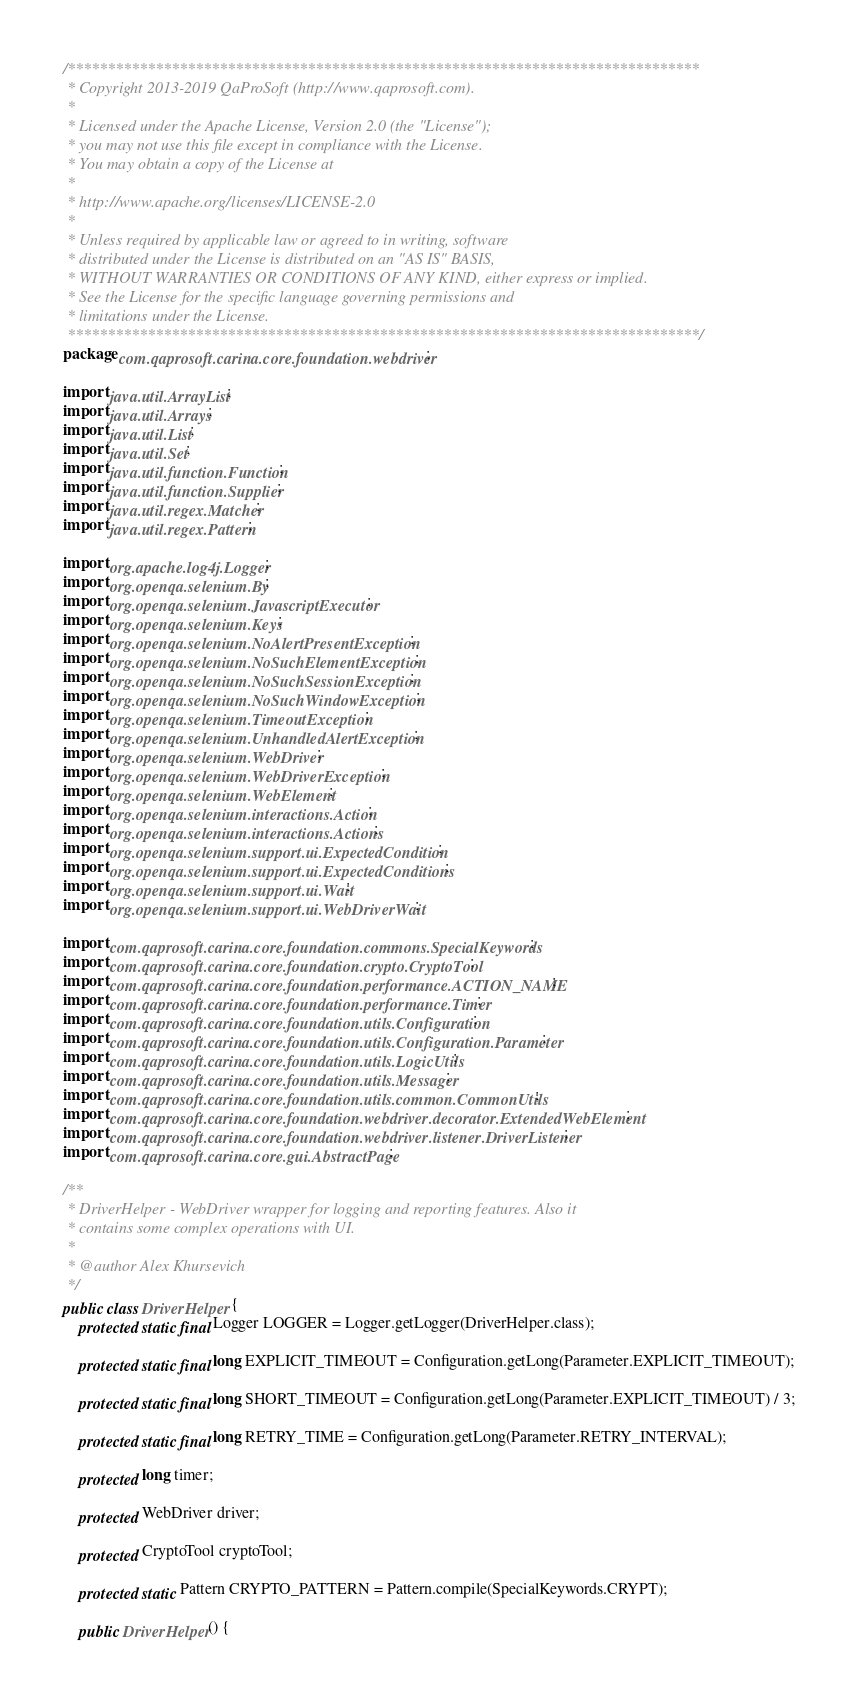Convert code to text. <code><loc_0><loc_0><loc_500><loc_500><_Java_>/*******************************************************************************
 * Copyright 2013-2019 QaProSoft (http://www.qaprosoft.com).
 *
 * Licensed under the Apache License, Version 2.0 (the "License");
 * you may not use this file except in compliance with the License.
 * You may obtain a copy of the License at
 *
 * http://www.apache.org/licenses/LICENSE-2.0
 *
 * Unless required by applicable law or agreed to in writing, software
 * distributed under the License is distributed on an "AS IS" BASIS,
 * WITHOUT WARRANTIES OR CONDITIONS OF ANY KIND, either express or implied.
 * See the License for the specific language governing permissions and
 * limitations under the License.
 *******************************************************************************/
package com.qaprosoft.carina.core.foundation.webdriver;

import java.util.ArrayList;
import java.util.Arrays;
import java.util.List;
import java.util.Set;
import java.util.function.Function;
import java.util.function.Supplier;
import java.util.regex.Matcher;
import java.util.regex.Pattern;

import org.apache.log4j.Logger;
import org.openqa.selenium.By;
import org.openqa.selenium.JavascriptExecutor;
import org.openqa.selenium.Keys;
import org.openqa.selenium.NoAlertPresentException;
import org.openqa.selenium.NoSuchElementException;
import org.openqa.selenium.NoSuchSessionException;
import org.openqa.selenium.NoSuchWindowException;
import org.openqa.selenium.TimeoutException;
import org.openqa.selenium.UnhandledAlertException;
import org.openqa.selenium.WebDriver;
import org.openqa.selenium.WebDriverException;
import org.openqa.selenium.WebElement;
import org.openqa.selenium.interactions.Action;
import org.openqa.selenium.interactions.Actions;
import org.openqa.selenium.support.ui.ExpectedCondition;
import org.openqa.selenium.support.ui.ExpectedConditions;
import org.openqa.selenium.support.ui.Wait;
import org.openqa.selenium.support.ui.WebDriverWait;

import com.qaprosoft.carina.core.foundation.commons.SpecialKeywords;
import com.qaprosoft.carina.core.foundation.crypto.CryptoTool;
import com.qaprosoft.carina.core.foundation.performance.ACTION_NAME;
import com.qaprosoft.carina.core.foundation.performance.Timer;
import com.qaprosoft.carina.core.foundation.utils.Configuration;
import com.qaprosoft.carina.core.foundation.utils.Configuration.Parameter;
import com.qaprosoft.carina.core.foundation.utils.LogicUtils;
import com.qaprosoft.carina.core.foundation.utils.Messager;
import com.qaprosoft.carina.core.foundation.utils.common.CommonUtils;
import com.qaprosoft.carina.core.foundation.webdriver.decorator.ExtendedWebElement;
import com.qaprosoft.carina.core.foundation.webdriver.listener.DriverListener;
import com.qaprosoft.carina.core.gui.AbstractPage;

/**
 * DriverHelper - WebDriver wrapper for logging and reporting features. Also it
 * contains some complex operations with UI.
 * 
 * @author Alex Khursevich
 */
public class DriverHelper {
    protected static final Logger LOGGER = Logger.getLogger(DriverHelper.class);

    protected static final long EXPLICIT_TIMEOUT = Configuration.getLong(Parameter.EXPLICIT_TIMEOUT);
    
    protected static final long SHORT_TIMEOUT = Configuration.getLong(Parameter.EXPLICIT_TIMEOUT) / 3;

    protected static final long RETRY_TIME = Configuration.getLong(Parameter.RETRY_INTERVAL);

    protected long timer;

    protected WebDriver driver;

    protected CryptoTool cryptoTool;

    protected static Pattern CRYPTO_PATTERN = Pattern.compile(SpecialKeywords.CRYPT);

    public DriverHelper() {</code> 